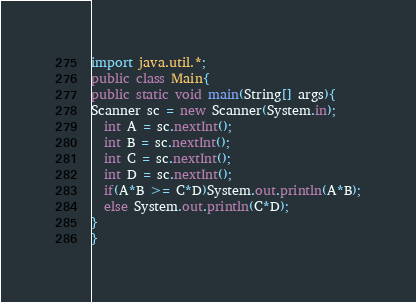Convert code to text. <code><loc_0><loc_0><loc_500><loc_500><_Java_>import java.util.*;
public class Main{
public static void main(String[] args){
Scanner sc = new Scanner(System.in);
  int A = sc.nextInt();
  int B = sc.nextInt();
  int C = sc.nextInt();
  int D = sc.nextInt();
  if(A*B >= C*D)System.out.println(A*B);
  else System.out.println(C*D);
}
}</code> 